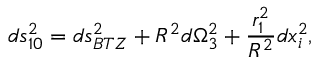<formula> <loc_0><loc_0><loc_500><loc_500>d s _ { 1 0 } ^ { 2 } = d s _ { B T Z } ^ { 2 } + R ^ { 2 } d \Omega _ { 3 } ^ { 2 } + { \frac { r _ { 1 } ^ { 2 } } { R ^ { 2 } } } d x _ { i } ^ { 2 } ,</formula> 